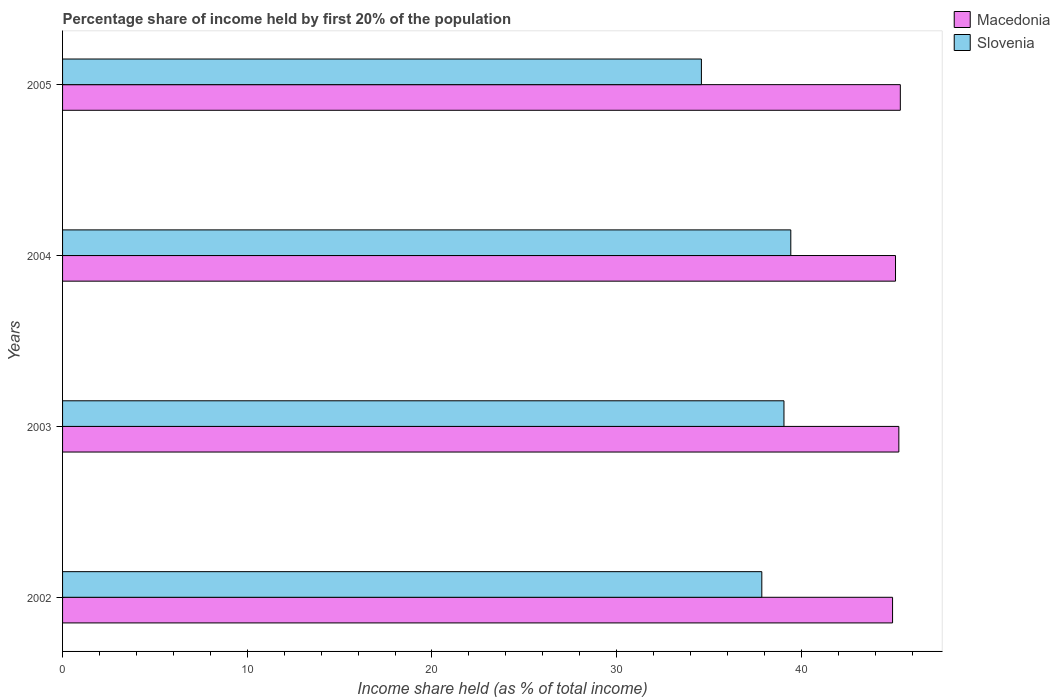How many different coloured bars are there?
Offer a very short reply. 2. How many groups of bars are there?
Keep it short and to the point. 4. Are the number of bars on each tick of the Y-axis equal?
Give a very brief answer. Yes. What is the share of income held by first 20% of the population in Slovenia in 2002?
Make the answer very short. 37.86. Across all years, what is the maximum share of income held by first 20% of the population in Macedonia?
Keep it short and to the point. 45.36. Across all years, what is the minimum share of income held by first 20% of the population in Macedonia?
Offer a very short reply. 44.94. What is the total share of income held by first 20% of the population in Macedonia in the graph?
Offer a very short reply. 180.68. What is the difference between the share of income held by first 20% of the population in Slovenia in 2002 and that in 2003?
Provide a succinct answer. -1.2. What is the difference between the share of income held by first 20% of the population in Macedonia in 2004 and the share of income held by first 20% of the population in Slovenia in 2002?
Offer a terse response. 7.24. What is the average share of income held by first 20% of the population in Slovenia per year?
Make the answer very short. 37.73. In the year 2003, what is the difference between the share of income held by first 20% of the population in Macedonia and share of income held by first 20% of the population in Slovenia?
Make the answer very short. 6.22. What is the ratio of the share of income held by first 20% of the population in Macedonia in 2003 to that in 2004?
Offer a terse response. 1. Is the difference between the share of income held by first 20% of the population in Macedonia in 2003 and 2005 greater than the difference between the share of income held by first 20% of the population in Slovenia in 2003 and 2005?
Your response must be concise. No. What is the difference between the highest and the second highest share of income held by first 20% of the population in Macedonia?
Make the answer very short. 0.08. What is the difference between the highest and the lowest share of income held by first 20% of the population in Slovenia?
Your response must be concise. 4.84. Is the sum of the share of income held by first 20% of the population in Macedonia in 2002 and 2004 greater than the maximum share of income held by first 20% of the population in Slovenia across all years?
Provide a short and direct response. Yes. What does the 1st bar from the top in 2005 represents?
Ensure brevity in your answer.  Slovenia. What does the 1st bar from the bottom in 2004 represents?
Your answer should be very brief. Macedonia. Are all the bars in the graph horizontal?
Offer a very short reply. Yes. Does the graph contain grids?
Your answer should be very brief. No. How many legend labels are there?
Your answer should be very brief. 2. How are the legend labels stacked?
Make the answer very short. Vertical. What is the title of the graph?
Your response must be concise. Percentage share of income held by first 20% of the population. Does "Gabon" appear as one of the legend labels in the graph?
Provide a succinct answer. No. What is the label or title of the X-axis?
Your answer should be compact. Income share held (as % of total income). What is the Income share held (as % of total income) of Macedonia in 2002?
Keep it short and to the point. 44.94. What is the Income share held (as % of total income) of Slovenia in 2002?
Provide a succinct answer. 37.86. What is the Income share held (as % of total income) in Macedonia in 2003?
Your response must be concise. 45.28. What is the Income share held (as % of total income) of Slovenia in 2003?
Provide a short and direct response. 39.06. What is the Income share held (as % of total income) in Macedonia in 2004?
Ensure brevity in your answer.  45.1. What is the Income share held (as % of total income) of Slovenia in 2004?
Make the answer very short. 39.43. What is the Income share held (as % of total income) of Macedonia in 2005?
Keep it short and to the point. 45.36. What is the Income share held (as % of total income) of Slovenia in 2005?
Offer a terse response. 34.59. Across all years, what is the maximum Income share held (as % of total income) of Macedonia?
Your answer should be very brief. 45.36. Across all years, what is the maximum Income share held (as % of total income) in Slovenia?
Make the answer very short. 39.43. Across all years, what is the minimum Income share held (as % of total income) of Macedonia?
Provide a short and direct response. 44.94. Across all years, what is the minimum Income share held (as % of total income) in Slovenia?
Offer a very short reply. 34.59. What is the total Income share held (as % of total income) in Macedonia in the graph?
Provide a succinct answer. 180.68. What is the total Income share held (as % of total income) in Slovenia in the graph?
Give a very brief answer. 150.94. What is the difference between the Income share held (as % of total income) in Macedonia in 2002 and that in 2003?
Your response must be concise. -0.34. What is the difference between the Income share held (as % of total income) of Macedonia in 2002 and that in 2004?
Offer a terse response. -0.16. What is the difference between the Income share held (as % of total income) of Slovenia in 2002 and that in 2004?
Provide a succinct answer. -1.57. What is the difference between the Income share held (as % of total income) of Macedonia in 2002 and that in 2005?
Your response must be concise. -0.42. What is the difference between the Income share held (as % of total income) of Slovenia in 2002 and that in 2005?
Provide a succinct answer. 3.27. What is the difference between the Income share held (as % of total income) of Macedonia in 2003 and that in 2004?
Give a very brief answer. 0.18. What is the difference between the Income share held (as % of total income) in Slovenia in 2003 and that in 2004?
Offer a terse response. -0.37. What is the difference between the Income share held (as % of total income) of Macedonia in 2003 and that in 2005?
Provide a succinct answer. -0.08. What is the difference between the Income share held (as % of total income) in Slovenia in 2003 and that in 2005?
Ensure brevity in your answer.  4.47. What is the difference between the Income share held (as % of total income) of Macedonia in 2004 and that in 2005?
Give a very brief answer. -0.26. What is the difference between the Income share held (as % of total income) of Slovenia in 2004 and that in 2005?
Provide a succinct answer. 4.84. What is the difference between the Income share held (as % of total income) in Macedonia in 2002 and the Income share held (as % of total income) in Slovenia in 2003?
Give a very brief answer. 5.88. What is the difference between the Income share held (as % of total income) in Macedonia in 2002 and the Income share held (as % of total income) in Slovenia in 2004?
Make the answer very short. 5.51. What is the difference between the Income share held (as % of total income) of Macedonia in 2002 and the Income share held (as % of total income) of Slovenia in 2005?
Keep it short and to the point. 10.35. What is the difference between the Income share held (as % of total income) in Macedonia in 2003 and the Income share held (as % of total income) in Slovenia in 2004?
Your response must be concise. 5.85. What is the difference between the Income share held (as % of total income) in Macedonia in 2003 and the Income share held (as % of total income) in Slovenia in 2005?
Your answer should be very brief. 10.69. What is the difference between the Income share held (as % of total income) in Macedonia in 2004 and the Income share held (as % of total income) in Slovenia in 2005?
Offer a very short reply. 10.51. What is the average Income share held (as % of total income) in Macedonia per year?
Provide a short and direct response. 45.17. What is the average Income share held (as % of total income) of Slovenia per year?
Provide a short and direct response. 37.73. In the year 2002, what is the difference between the Income share held (as % of total income) in Macedonia and Income share held (as % of total income) in Slovenia?
Your response must be concise. 7.08. In the year 2003, what is the difference between the Income share held (as % of total income) in Macedonia and Income share held (as % of total income) in Slovenia?
Ensure brevity in your answer.  6.22. In the year 2004, what is the difference between the Income share held (as % of total income) of Macedonia and Income share held (as % of total income) of Slovenia?
Offer a very short reply. 5.67. In the year 2005, what is the difference between the Income share held (as % of total income) of Macedonia and Income share held (as % of total income) of Slovenia?
Offer a terse response. 10.77. What is the ratio of the Income share held (as % of total income) of Macedonia in 2002 to that in 2003?
Your answer should be very brief. 0.99. What is the ratio of the Income share held (as % of total income) of Slovenia in 2002 to that in 2003?
Provide a succinct answer. 0.97. What is the ratio of the Income share held (as % of total income) in Macedonia in 2002 to that in 2004?
Your response must be concise. 1. What is the ratio of the Income share held (as % of total income) in Slovenia in 2002 to that in 2004?
Give a very brief answer. 0.96. What is the ratio of the Income share held (as % of total income) in Slovenia in 2002 to that in 2005?
Give a very brief answer. 1.09. What is the ratio of the Income share held (as % of total income) in Macedonia in 2003 to that in 2004?
Your answer should be compact. 1. What is the ratio of the Income share held (as % of total income) in Slovenia in 2003 to that in 2004?
Provide a short and direct response. 0.99. What is the ratio of the Income share held (as % of total income) of Macedonia in 2003 to that in 2005?
Offer a very short reply. 1. What is the ratio of the Income share held (as % of total income) in Slovenia in 2003 to that in 2005?
Give a very brief answer. 1.13. What is the ratio of the Income share held (as % of total income) in Slovenia in 2004 to that in 2005?
Provide a succinct answer. 1.14. What is the difference between the highest and the second highest Income share held (as % of total income) of Macedonia?
Offer a terse response. 0.08. What is the difference between the highest and the second highest Income share held (as % of total income) in Slovenia?
Offer a terse response. 0.37. What is the difference between the highest and the lowest Income share held (as % of total income) in Macedonia?
Give a very brief answer. 0.42. What is the difference between the highest and the lowest Income share held (as % of total income) of Slovenia?
Offer a terse response. 4.84. 